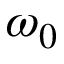<formula> <loc_0><loc_0><loc_500><loc_500>\omega _ { 0 }</formula> 